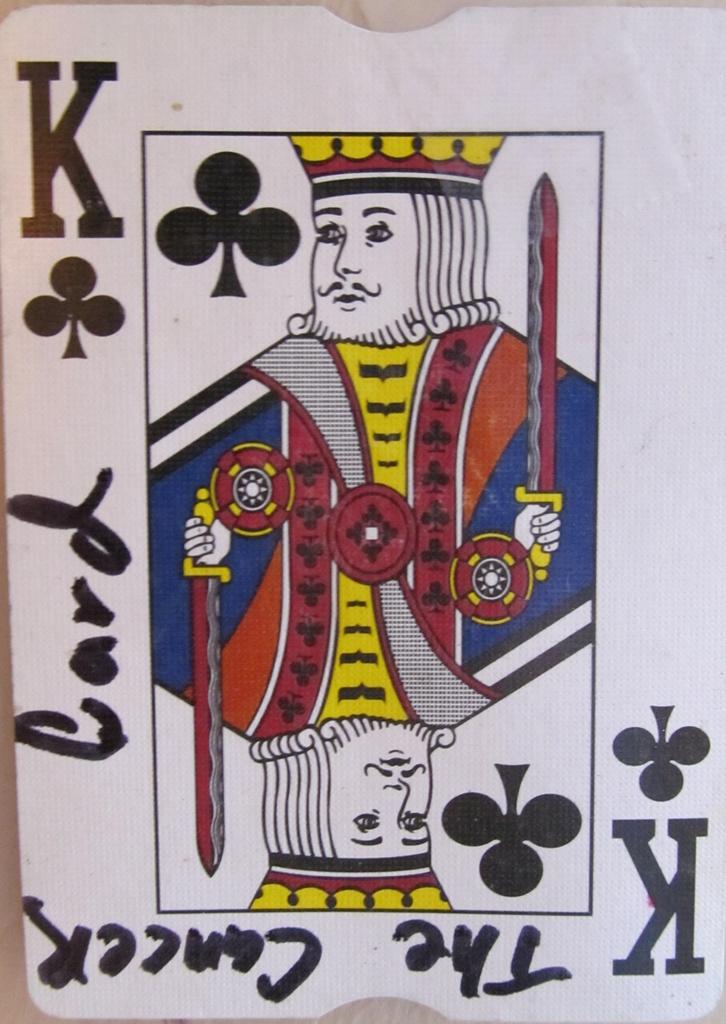What does the hand writing state?
Keep it short and to the point. The cancer card. What letter is in the top right cornor?
Keep it short and to the point. K. 